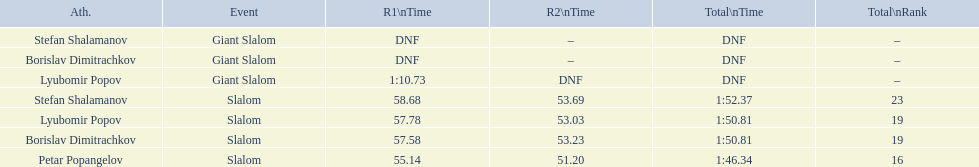What is the number of athletes to finish race one in the giant slalom? 1. 